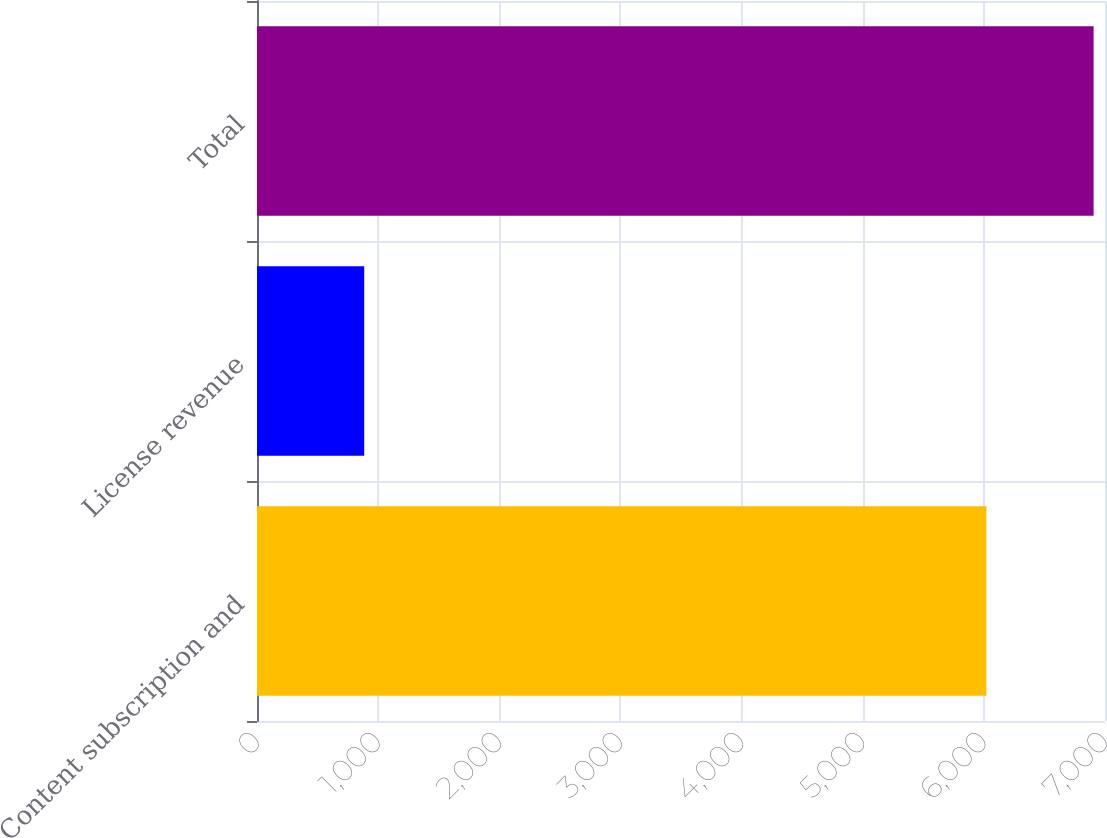<chart> <loc_0><loc_0><loc_500><loc_500><bar_chart><fcel>Content subscription and<fcel>License revenue<fcel>Total<nl><fcel>6021<fcel>885<fcel>6906<nl></chart> 